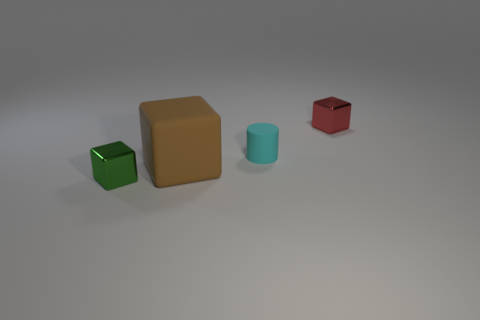Is there any other thing that is the same size as the brown rubber cube?
Offer a very short reply. No. Is the number of small red things in front of the small matte cylinder less than the number of small metal things that are on the left side of the small red cube?
Provide a succinct answer. Yes. How many balls are small cyan things or tiny green metallic objects?
Make the answer very short. 0. Does the small cube behind the small green metal cube have the same material as the cylinder behind the tiny green thing?
Provide a succinct answer. No. There is a cyan matte object that is the same size as the red thing; what is its shape?
Your answer should be very brief. Cylinder. How many other objects are there of the same color as the tiny cylinder?
Make the answer very short. 0. What number of brown things are rubber cylinders or matte blocks?
Provide a succinct answer. 1. There is a shiny thing that is to the right of the large cube; does it have the same shape as the metal object that is on the left side of the red shiny object?
Give a very brief answer. Yes. What number of other objects are the same material as the cyan object?
Your response must be concise. 1. There is a metallic cube to the right of the cube that is in front of the rubber block; are there any red blocks that are behind it?
Provide a succinct answer. No. 